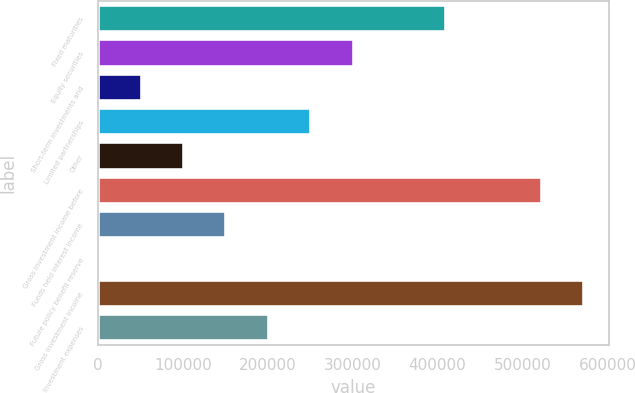Convert chart to OTSL. <chart><loc_0><loc_0><loc_500><loc_500><bar_chart><fcel>Fixed maturities<fcel>Equity securities<fcel>Short-term investments and<fcel>Limited partnerships<fcel>Other<fcel>Gross investment income before<fcel>Funds held interest income<fcel>Future policy benefit reserve<fcel>Gross investment income<fcel>Investment expenses<nl><fcel>410337<fcel>300972<fcel>51522.9<fcel>251082<fcel>101413<fcel>522975<fcel>151303<fcel>1633<fcel>572865<fcel>201193<nl></chart> 